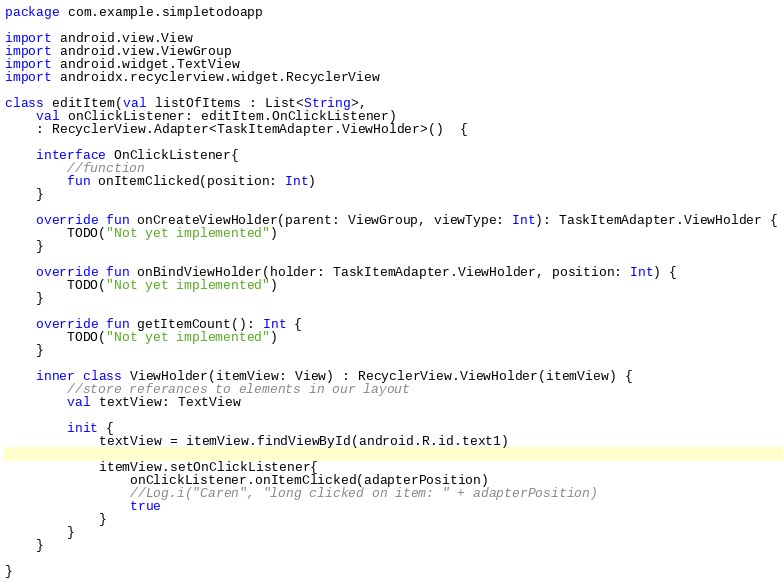<code> <loc_0><loc_0><loc_500><loc_500><_Kotlin_>package com.example.simpletodoapp

import android.view.View
import android.view.ViewGroup
import android.widget.TextView
import androidx.recyclerview.widget.RecyclerView

class editItem(val listOfItems : List<String>,
    val onClickListener: editItem.OnClickListener)
    : RecyclerView.Adapter<TaskItemAdapter.ViewHolder>()  {

    interface OnClickListener{
        //function
        fun onItemClicked(position: Int)
    }

    override fun onCreateViewHolder(parent: ViewGroup, viewType: Int): TaskItemAdapter.ViewHolder {
        TODO("Not yet implemented")
    }

    override fun onBindViewHolder(holder: TaskItemAdapter.ViewHolder, position: Int) {
        TODO("Not yet implemented")
    }

    override fun getItemCount(): Int {
        TODO("Not yet implemented")
    }

    inner class ViewHolder(itemView: View) : RecyclerView.ViewHolder(itemView) {
        //store referances to elements in our layout
        val textView: TextView

        init {
            textView = itemView.findViewById(android.R.id.text1)

            itemView.setOnClickListener{
                onClickListener.onItemClicked(adapterPosition)
                //Log.i("Caren", "long clicked on item: " + adapterPosition)
                true
            }
        }
    }

}</code> 